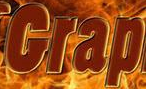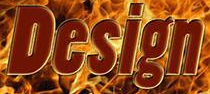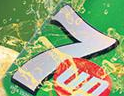What text is displayed in these images sequentially, separated by a semicolon? Grap; Design; 7 